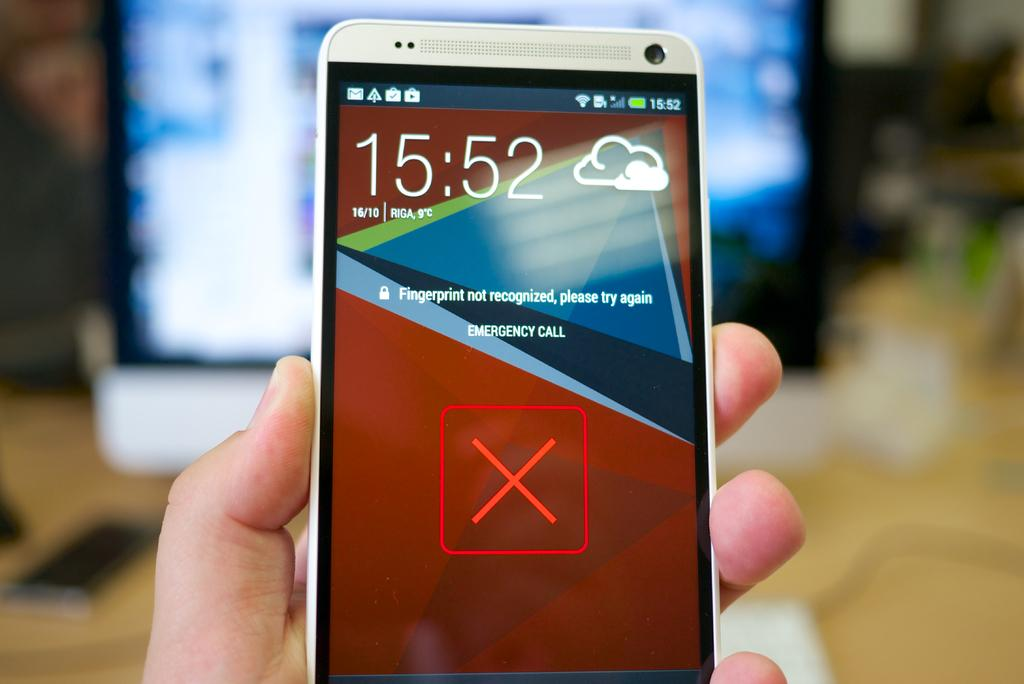<image>
Provide a brief description of the given image. A phone screen has a notification on it that the fingerprint was not recognized. 